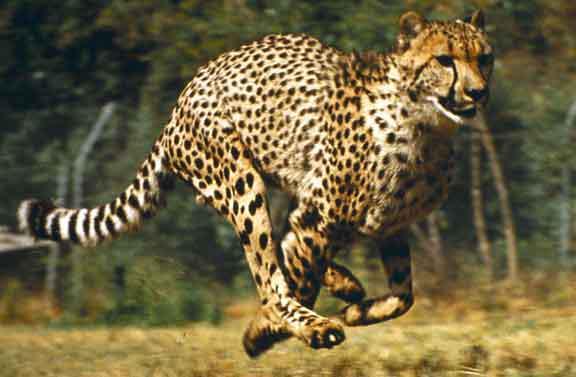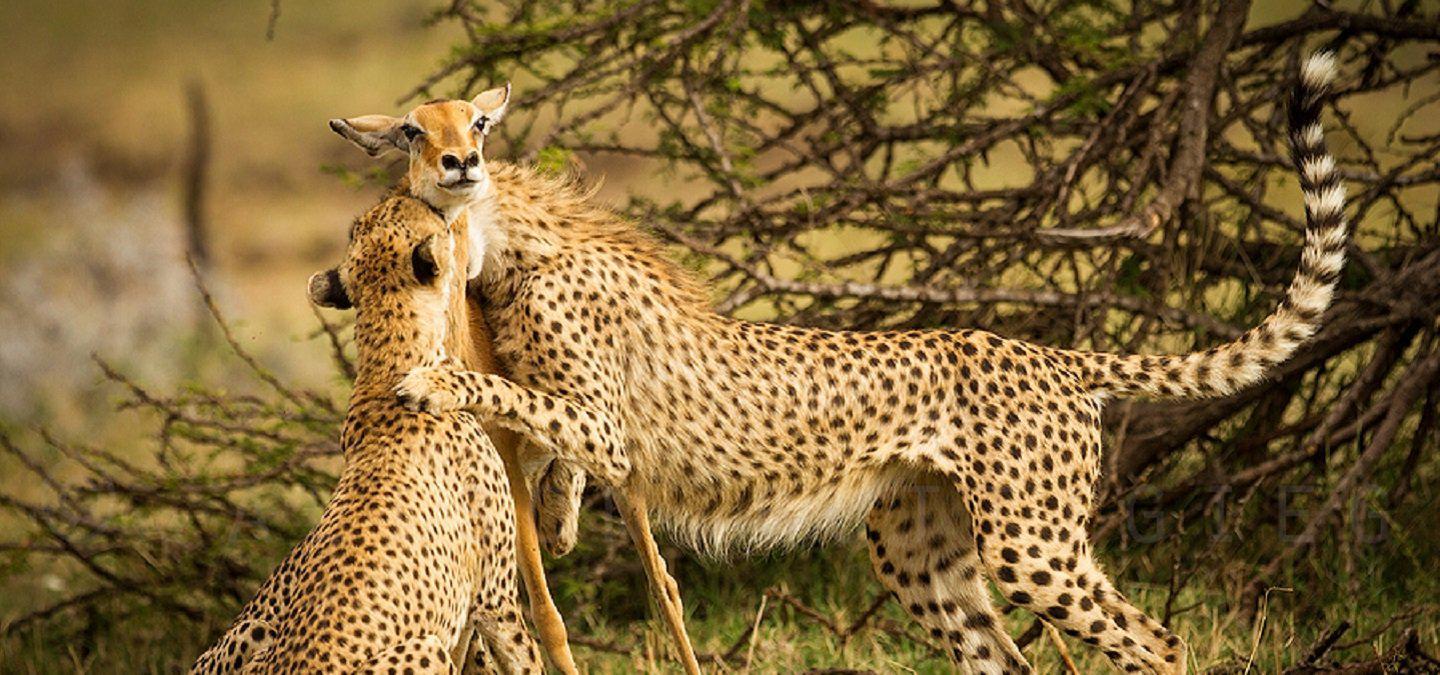The first image is the image on the left, the second image is the image on the right. For the images shown, is this caption "A cheetah's paw is on a deer's face in at last one of the images." true? Answer yes or no. No. 